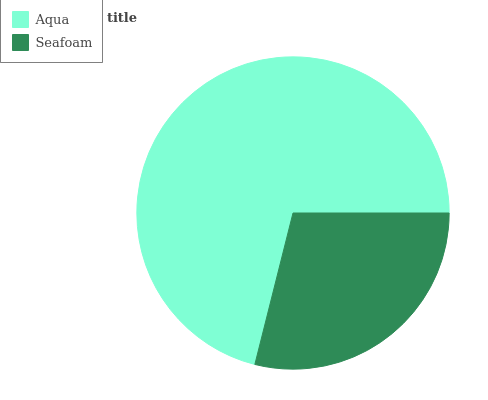Is Seafoam the minimum?
Answer yes or no. Yes. Is Aqua the maximum?
Answer yes or no. Yes. Is Seafoam the maximum?
Answer yes or no. No. Is Aqua greater than Seafoam?
Answer yes or no. Yes. Is Seafoam less than Aqua?
Answer yes or no. Yes. Is Seafoam greater than Aqua?
Answer yes or no. No. Is Aqua less than Seafoam?
Answer yes or no. No. Is Aqua the high median?
Answer yes or no. Yes. Is Seafoam the low median?
Answer yes or no. Yes. Is Seafoam the high median?
Answer yes or no. No. Is Aqua the low median?
Answer yes or no. No. 